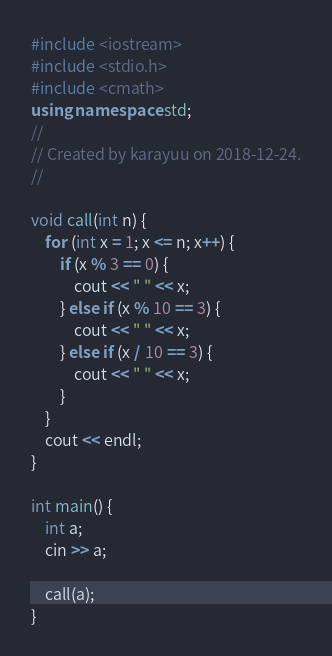Convert code to text. <code><loc_0><loc_0><loc_500><loc_500><_C++_>#include <iostream>
#include <stdio.h>
#include <cmath>
using namespace std;
//
// Created by karayuu on 2018-12-24.
//

void call(int n) {
    for (int x = 1; x <= n; x++) {
        if (x % 3 == 0) {
            cout << " " << x;
        } else if (x % 10 == 3) {
            cout << " " << x;
        } else if (x / 10 == 3) {
            cout << " " << x;
        }
    }
    cout << endl;
}

int main() {
    int a;
    cin >> a;

    call(a);
}
</code> 